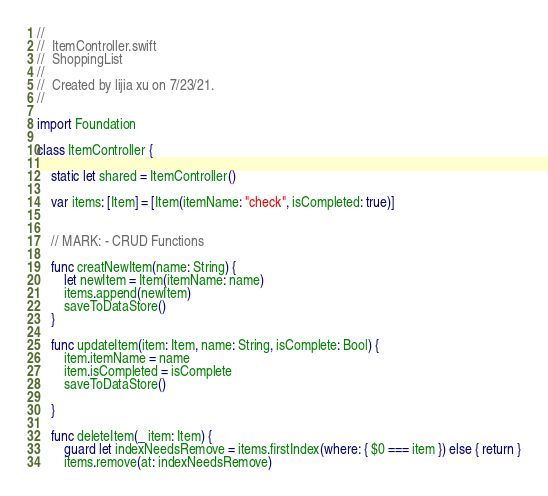<code> <loc_0><loc_0><loc_500><loc_500><_Swift_>//
//  ItemController.swift
//  ShoppingList
//
//  Created by lijia xu on 7/23/21.
//

import Foundation

class ItemController {
    
    static let shared = ItemController()
    
    var items: [Item] = [Item(itemName: "check", isCompleted: true)]
    
    
    // MARK: - CRUD Functions
    
    func creatNewItem(name: String) {
        let newItem = Item(itemName: name)
        items.append(newItem)
        saveToDataStore()
    }
    
    func updateItem(item: Item, name: String, isComplete: Bool) {
        item.itemName = name
        item.isCompleted = isComplete
        saveToDataStore()
        
    }
    
    func deleteItem(_ item: Item) {
        guard let indexNeedsRemove = items.firstIndex(where: { $0 === item }) else { return }
        items.remove(at: indexNeedsRemove)</code> 